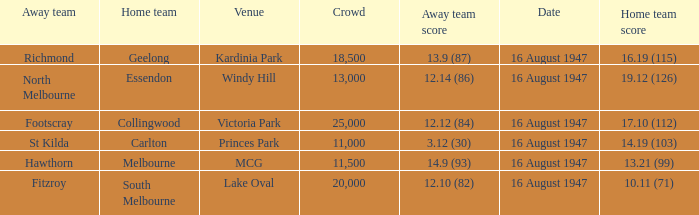What venue had footscray play at it? Victoria Park. Could you help me parse every detail presented in this table? {'header': ['Away team', 'Home team', 'Venue', 'Crowd', 'Away team score', 'Date', 'Home team score'], 'rows': [['Richmond', 'Geelong', 'Kardinia Park', '18,500', '13.9 (87)', '16 August 1947', '16.19 (115)'], ['North Melbourne', 'Essendon', 'Windy Hill', '13,000', '12.14 (86)', '16 August 1947', '19.12 (126)'], ['Footscray', 'Collingwood', 'Victoria Park', '25,000', '12.12 (84)', '16 August 1947', '17.10 (112)'], ['St Kilda', 'Carlton', 'Princes Park', '11,000', '3.12 (30)', '16 August 1947', '14.19 (103)'], ['Hawthorn', 'Melbourne', 'MCG', '11,500', '14.9 (93)', '16 August 1947', '13.21 (99)'], ['Fitzroy', 'South Melbourne', 'Lake Oval', '20,000', '12.10 (82)', '16 August 1947', '10.11 (71)']]} 